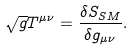Convert formula to latex. <formula><loc_0><loc_0><loc_500><loc_500>\sqrt { g } T ^ { \mu \nu } = \frac { \delta S _ { S M } } { \delta g _ { \mu \nu } } .</formula> 